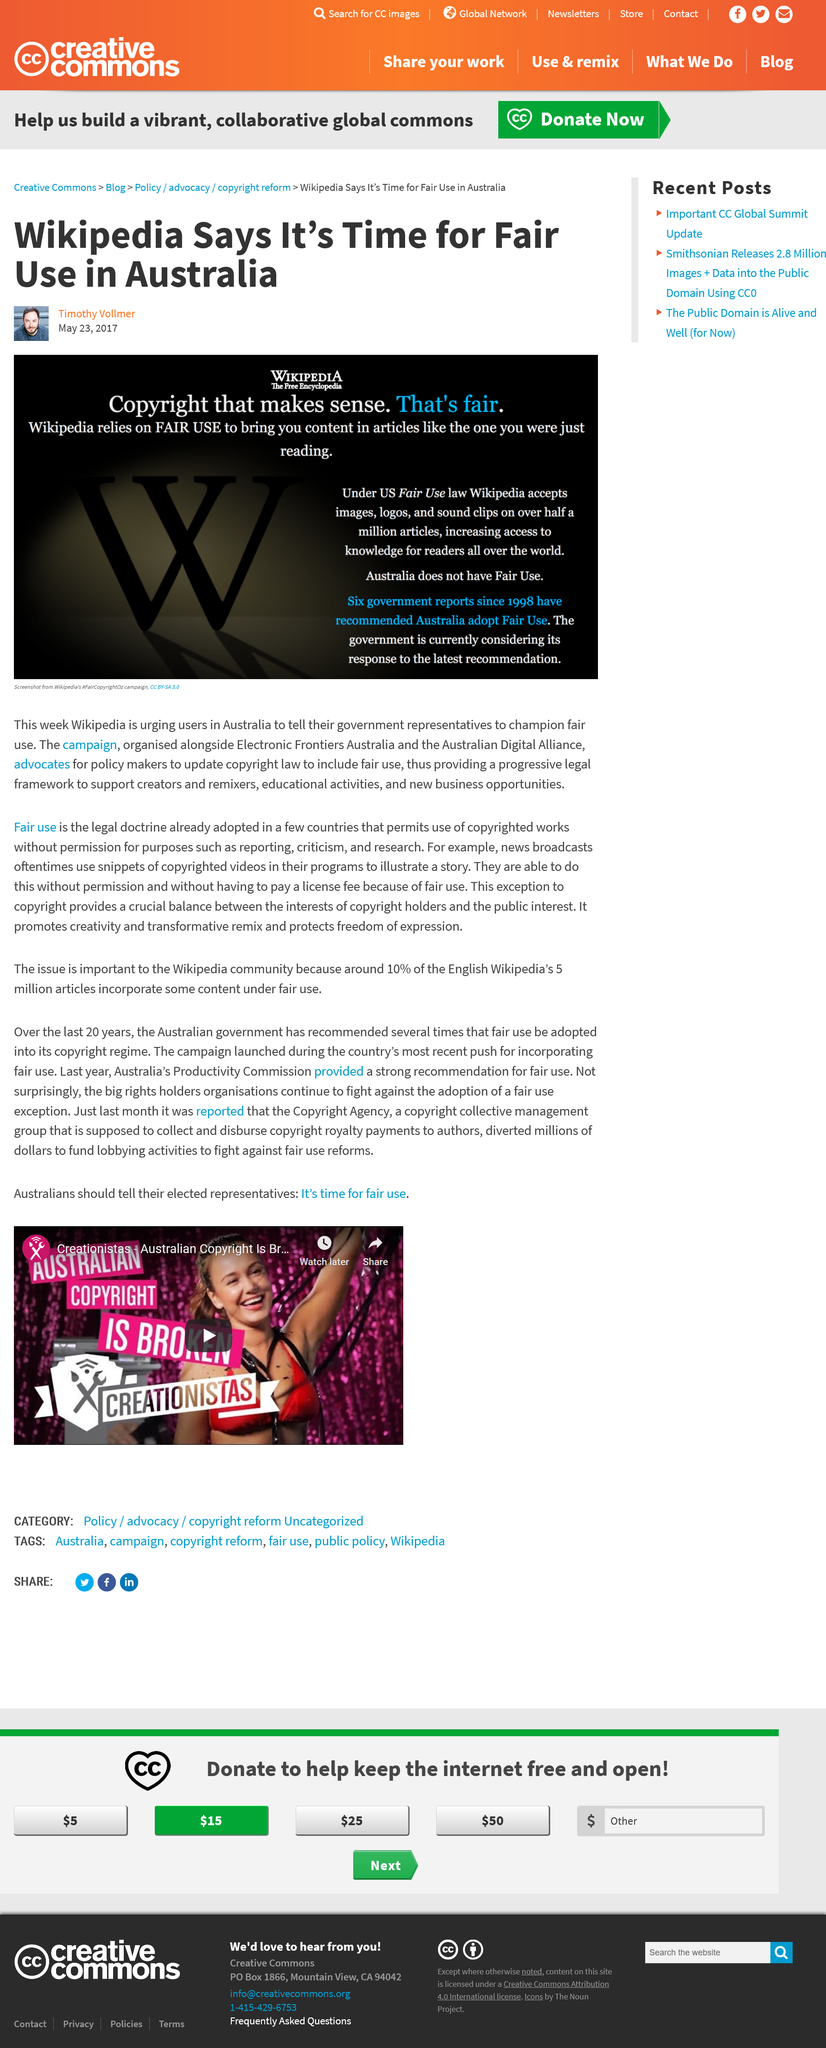List a handful of essential elements in this visual. Six government reports since 1998 have recommended adopting Fair Use in Australia. Wikipedia is calling on its users in Australia to encourage their elected officials to support fair use. Under the Fair Use law in the US, Wikipedia accepts images, logos, and sound clips on over half a million articles. This is in accordance with the guidelines set by Wikipedia. 